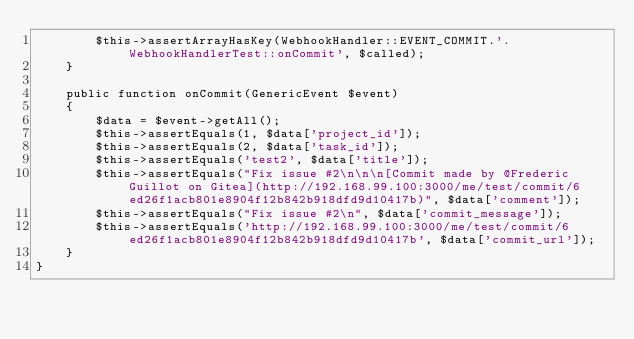Convert code to text. <code><loc_0><loc_0><loc_500><loc_500><_PHP_>        $this->assertArrayHasKey(WebhookHandler::EVENT_COMMIT.'.WebhookHandlerTest::onCommit', $called);
    }

    public function onCommit(GenericEvent $event)
    {
        $data = $event->getAll();
        $this->assertEquals(1, $data['project_id']);
        $this->assertEquals(2, $data['task_id']);
        $this->assertEquals('test2', $data['title']);
        $this->assertEquals("Fix issue #2\n\n\n[Commit made by @Frederic Guillot on Gitea](http://192.168.99.100:3000/me/test/commit/6ed26f1acb801e8904f12b842b918dfd9d10417b)", $data['comment']);
        $this->assertEquals("Fix issue #2\n", $data['commit_message']);
        $this->assertEquals('http://192.168.99.100:3000/me/test/commit/6ed26f1acb801e8904f12b842b918dfd9d10417b', $data['commit_url']);
    }
}
</code> 